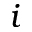<formula> <loc_0><loc_0><loc_500><loc_500>i</formula> 